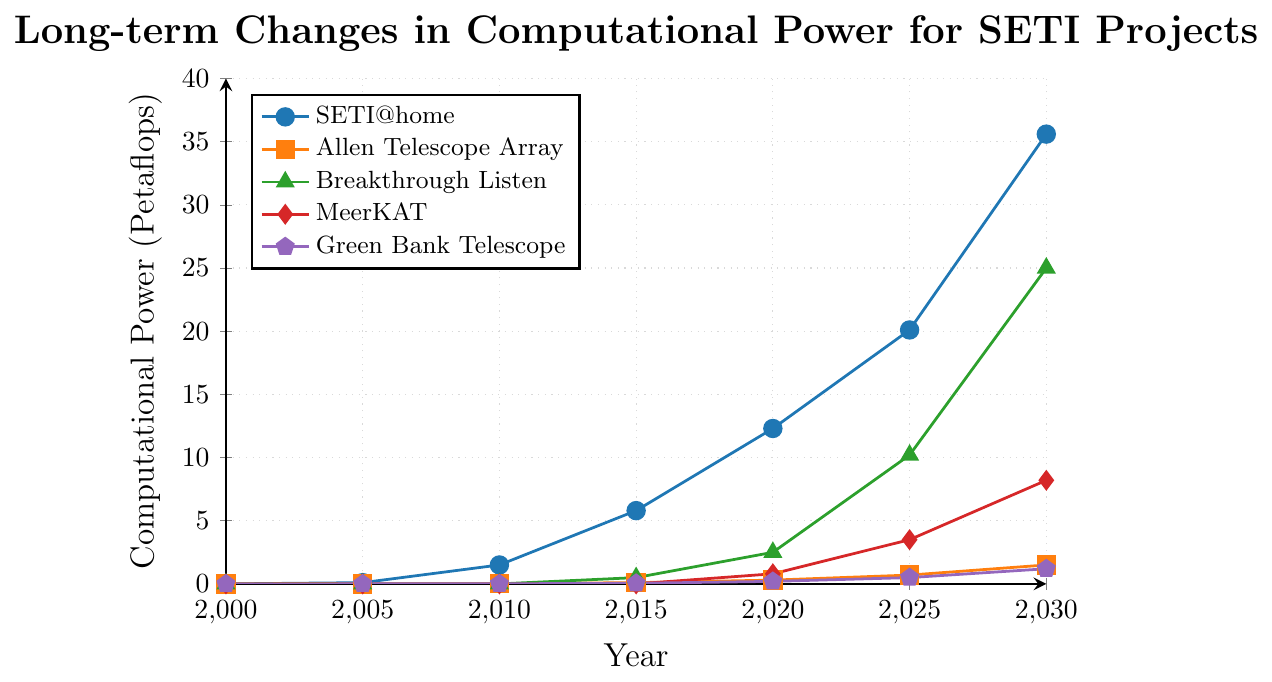What's the overall trend in computational power for SETI@home from 2000 to 2030? The computational power for SETI@home consistently increases from 0.001 petaflops in 2000 to 35.6 petaflops in 2030. This trend shows a steady upward growth in computational power over the 30-year period.
Answer: It increases Which project had the highest computational power in 2020 and what was its value? In 2020, SETI@home had the highest computational power, reaching 12.3 petaflops, more than any other project listed.
Answer: SETI@home, 12.3 petaflops Compare the computational power of Allen Telescope Array and Breakthrough Listen in 2025. Which one is greater and by how much? In 2025, the Allen Telescope Array had 0.7 petaflops, while Breakthrough Listen had 10.2 petaflops. By subtracting these two values (10.2 - 0.7), Breakthrough Listen has 9.5 petaflops more computational power than Allen Telescope Array.
Answer: Breakthrough Listen by 9.5 petaflops How many years did it take for Breakthrough Listen to reach 10 petaflops starting from zero? Breakthrough Listen started at 0 petaflops in 2010 and reached 10.2 petaflops by 2025. This took 15 years (2025 - 2010).
Answer: 15 years What is the difference in computational power between MeerKAT and Green Bank Telescope in 2030? In 2030, MeerKAT has 8.2 petaflops, and Green Bank Telescope has 1.2 petaflops. The difference is calculated as 8.2 - 1.2
Answer: 7 petaflops During the period from 2000 to 2030, which project showed the most significant growth in computational power? SETI@home showed the most significant growth, increasing from 0.001 petaflops in 2000 to 35.6 petaflops in 2030. This is the largest increase among the projects.
Answer: SETI@home What color represents the Breakthrough Listen project on the chart? The Breakthrough Listen project is represented by a green line with a triangle mark.
Answer: Green Calculate the total computational power used by all the projects in 2015. In 2015, the computational power of all projects: SETI@home: 5.8, Allen Telescope Array: 0.1, Breakthrough Listen: 0.5, MeerKAT: 0, Green Bank Telescope: 0.05. Sum these values: 5.8 + 0.1 + 0.5 + 0 + 0.05 = 6.45
Answer: 6.45 petaflops Which project had no computational power until 2015, and when does it first appear with measurable power on the chart? Both Breakthrough Listen and MeerKAT had no computational power until 2015. Breakthrough Listen first appears with 0.5 petaflops and MeerKAT first appears with 0.8 petaflops in 2020.
Answer: Breakthrough Listen and MeerKAT, Breakthrough Listen in 2015, MeerKAT in 2020 